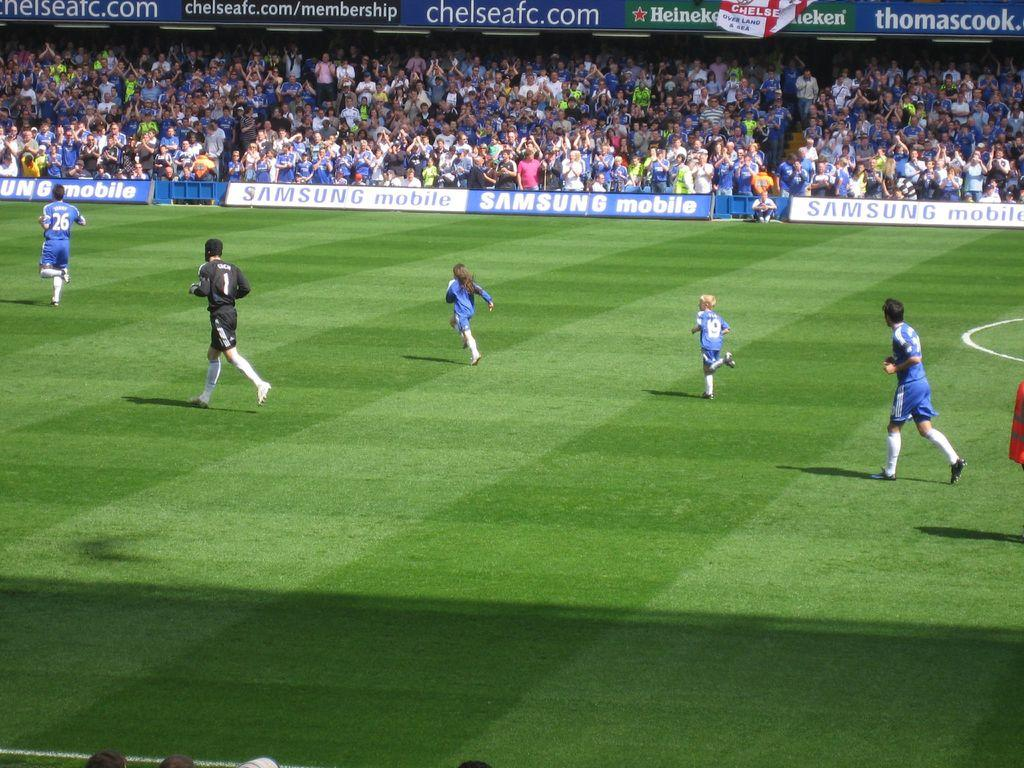Provide a one-sentence caption for the provided image. a soccer game with sideline signs that read : SAMSUNG Mobile. 